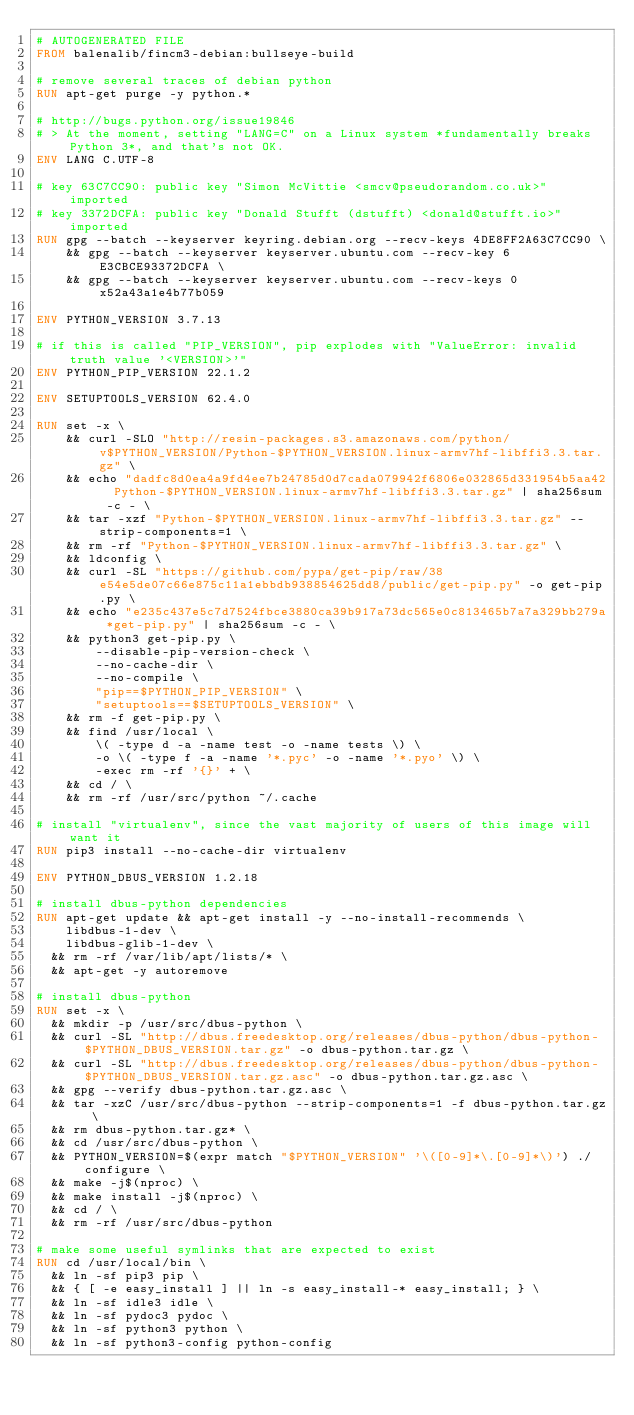Convert code to text. <code><loc_0><loc_0><loc_500><loc_500><_Dockerfile_># AUTOGENERATED FILE
FROM balenalib/fincm3-debian:bullseye-build

# remove several traces of debian python
RUN apt-get purge -y python.*

# http://bugs.python.org/issue19846
# > At the moment, setting "LANG=C" on a Linux system *fundamentally breaks Python 3*, and that's not OK.
ENV LANG C.UTF-8

# key 63C7CC90: public key "Simon McVittie <smcv@pseudorandom.co.uk>" imported
# key 3372DCFA: public key "Donald Stufft (dstufft) <donald@stufft.io>" imported
RUN gpg --batch --keyserver keyring.debian.org --recv-keys 4DE8FF2A63C7CC90 \
    && gpg --batch --keyserver keyserver.ubuntu.com --recv-key 6E3CBCE93372DCFA \
    && gpg --batch --keyserver keyserver.ubuntu.com --recv-keys 0x52a43a1e4b77b059

ENV PYTHON_VERSION 3.7.13

# if this is called "PIP_VERSION", pip explodes with "ValueError: invalid truth value '<VERSION>'"
ENV PYTHON_PIP_VERSION 22.1.2

ENV SETUPTOOLS_VERSION 62.4.0

RUN set -x \
    && curl -SLO "http://resin-packages.s3.amazonaws.com/python/v$PYTHON_VERSION/Python-$PYTHON_VERSION.linux-armv7hf-libffi3.3.tar.gz" \
    && echo "dadfc8d0ea4a9fd4ee7b24785d0d7cada079942f6806e032865d331954b5aa42  Python-$PYTHON_VERSION.linux-armv7hf-libffi3.3.tar.gz" | sha256sum -c - \
    && tar -xzf "Python-$PYTHON_VERSION.linux-armv7hf-libffi3.3.tar.gz" --strip-components=1 \
    && rm -rf "Python-$PYTHON_VERSION.linux-armv7hf-libffi3.3.tar.gz" \
    && ldconfig \
    && curl -SL "https://github.com/pypa/get-pip/raw/38e54e5de07c66e875c11a1ebbdb938854625dd8/public/get-pip.py" -o get-pip.py \
    && echo "e235c437e5c7d7524fbce3880ca39b917a73dc565e0c813465b7a7a329bb279a *get-pip.py" | sha256sum -c - \
    && python3 get-pip.py \
        --disable-pip-version-check \
        --no-cache-dir \
        --no-compile \
        "pip==$PYTHON_PIP_VERSION" \
        "setuptools==$SETUPTOOLS_VERSION" \
    && rm -f get-pip.py \
    && find /usr/local \
        \( -type d -a -name test -o -name tests \) \
        -o \( -type f -a -name '*.pyc' -o -name '*.pyo' \) \
        -exec rm -rf '{}' + \
    && cd / \
    && rm -rf /usr/src/python ~/.cache

# install "virtualenv", since the vast majority of users of this image will want it
RUN pip3 install --no-cache-dir virtualenv

ENV PYTHON_DBUS_VERSION 1.2.18

# install dbus-python dependencies 
RUN apt-get update && apt-get install -y --no-install-recommends \
		libdbus-1-dev \
		libdbus-glib-1-dev \
	&& rm -rf /var/lib/apt/lists/* \
	&& apt-get -y autoremove

# install dbus-python
RUN set -x \
	&& mkdir -p /usr/src/dbus-python \
	&& curl -SL "http://dbus.freedesktop.org/releases/dbus-python/dbus-python-$PYTHON_DBUS_VERSION.tar.gz" -o dbus-python.tar.gz \
	&& curl -SL "http://dbus.freedesktop.org/releases/dbus-python/dbus-python-$PYTHON_DBUS_VERSION.tar.gz.asc" -o dbus-python.tar.gz.asc \
	&& gpg --verify dbus-python.tar.gz.asc \
	&& tar -xzC /usr/src/dbus-python --strip-components=1 -f dbus-python.tar.gz \
	&& rm dbus-python.tar.gz* \
	&& cd /usr/src/dbus-python \
	&& PYTHON_VERSION=$(expr match "$PYTHON_VERSION" '\([0-9]*\.[0-9]*\)') ./configure \
	&& make -j$(nproc) \
	&& make install -j$(nproc) \
	&& cd / \
	&& rm -rf /usr/src/dbus-python

# make some useful symlinks that are expected to exist
RUN cd /usr/local/bin \
	&& ln -sf pip3 pip \
	&& { [ -e easy_install ] || ln -s easy_install-* easy_install; } \
	&& ln -sf idle3 idle \
	&& ln -sf pydoc3 pydoc \
	&& ln -sf python3 python \
	&& ln -sf python3-config python-config
</code> 